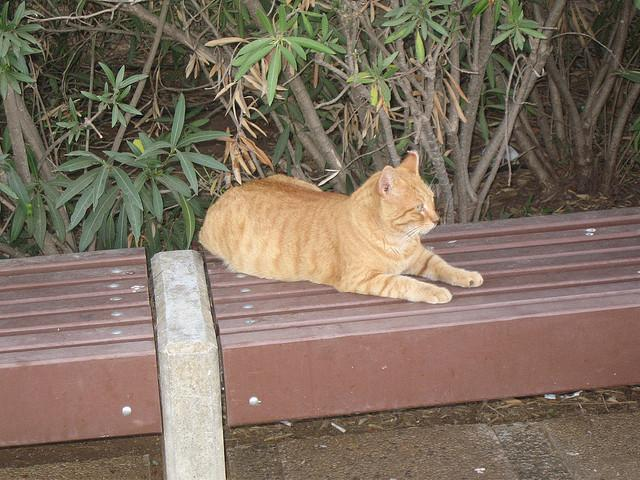What word describes this animal?

Choices:
A) canine
B) bovine
C) equine
D) feline feline 